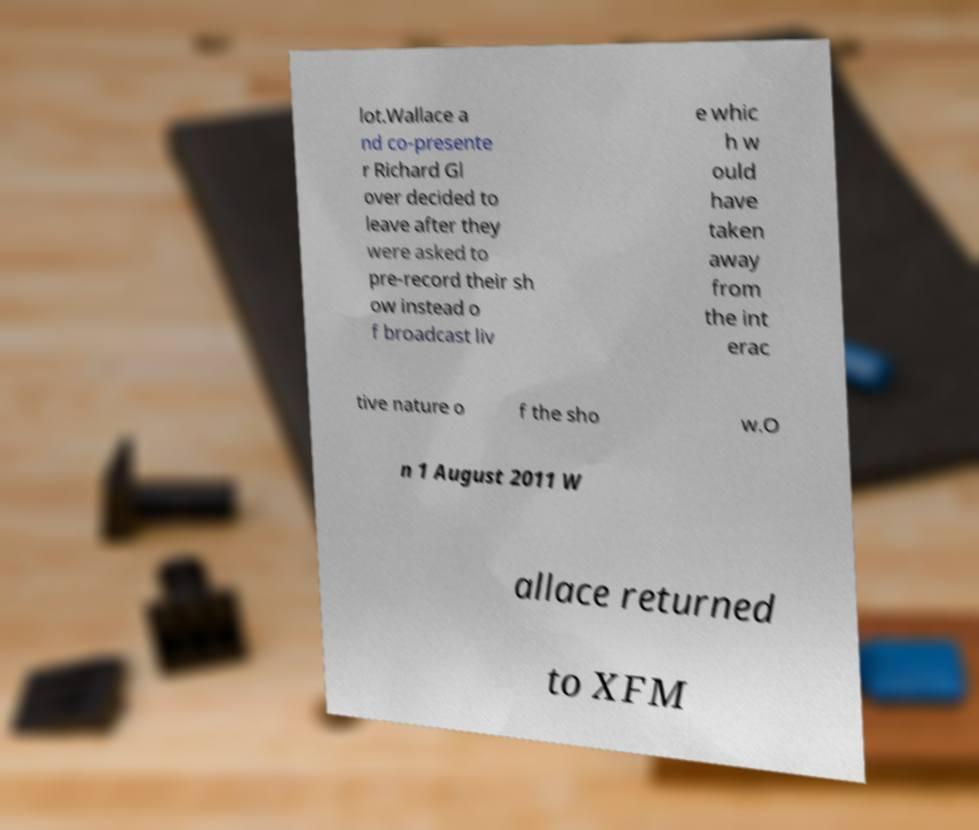Please read and relay the text visible in this image. What does it say? lot.Wallace a nd co-presente r Richard Gl over decided to leave after they were asked to pre-record their sh ow instead o f broadcast liv e whic h w ould have taken away from the int erac tive nature o f the sho w.O n 1 August 2011 W allace returned to XFM 